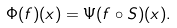<formula> <loc_0><loc_0><loc_500><loc_500>\Phi ( f ) ( x ) = \Psi ( f \circ S ) ( x ) .</formula> 